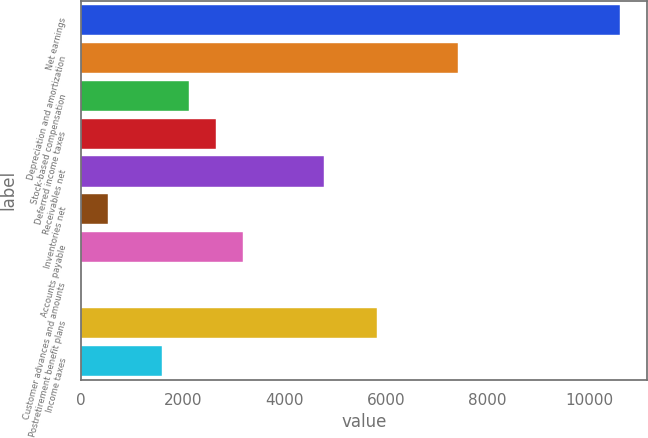Convert chart to OTSL. <chart><loc_0><loc_0><loc_500><loc_500><bar_chart><fcel>Net earnings<fcel>Depreciation and amortization<fcel>Stock-based compensation<fcel>Deferred income taxes<fcel>Receivables net<fcel>Inventories net<fcel>Accounts payable<fcel>Customer advances and amounts<fcel>Postretirement benefit plans<fcel>Income taxes<nl><fcel>10601<fcel>7421.6<fcel>2122.6<fcel>2652.5<fcel>4772.1<fcel>532.9<fcel>3182.4<fcel>3<fcel>5831.9<fcel>1592.7<nl></chart> 